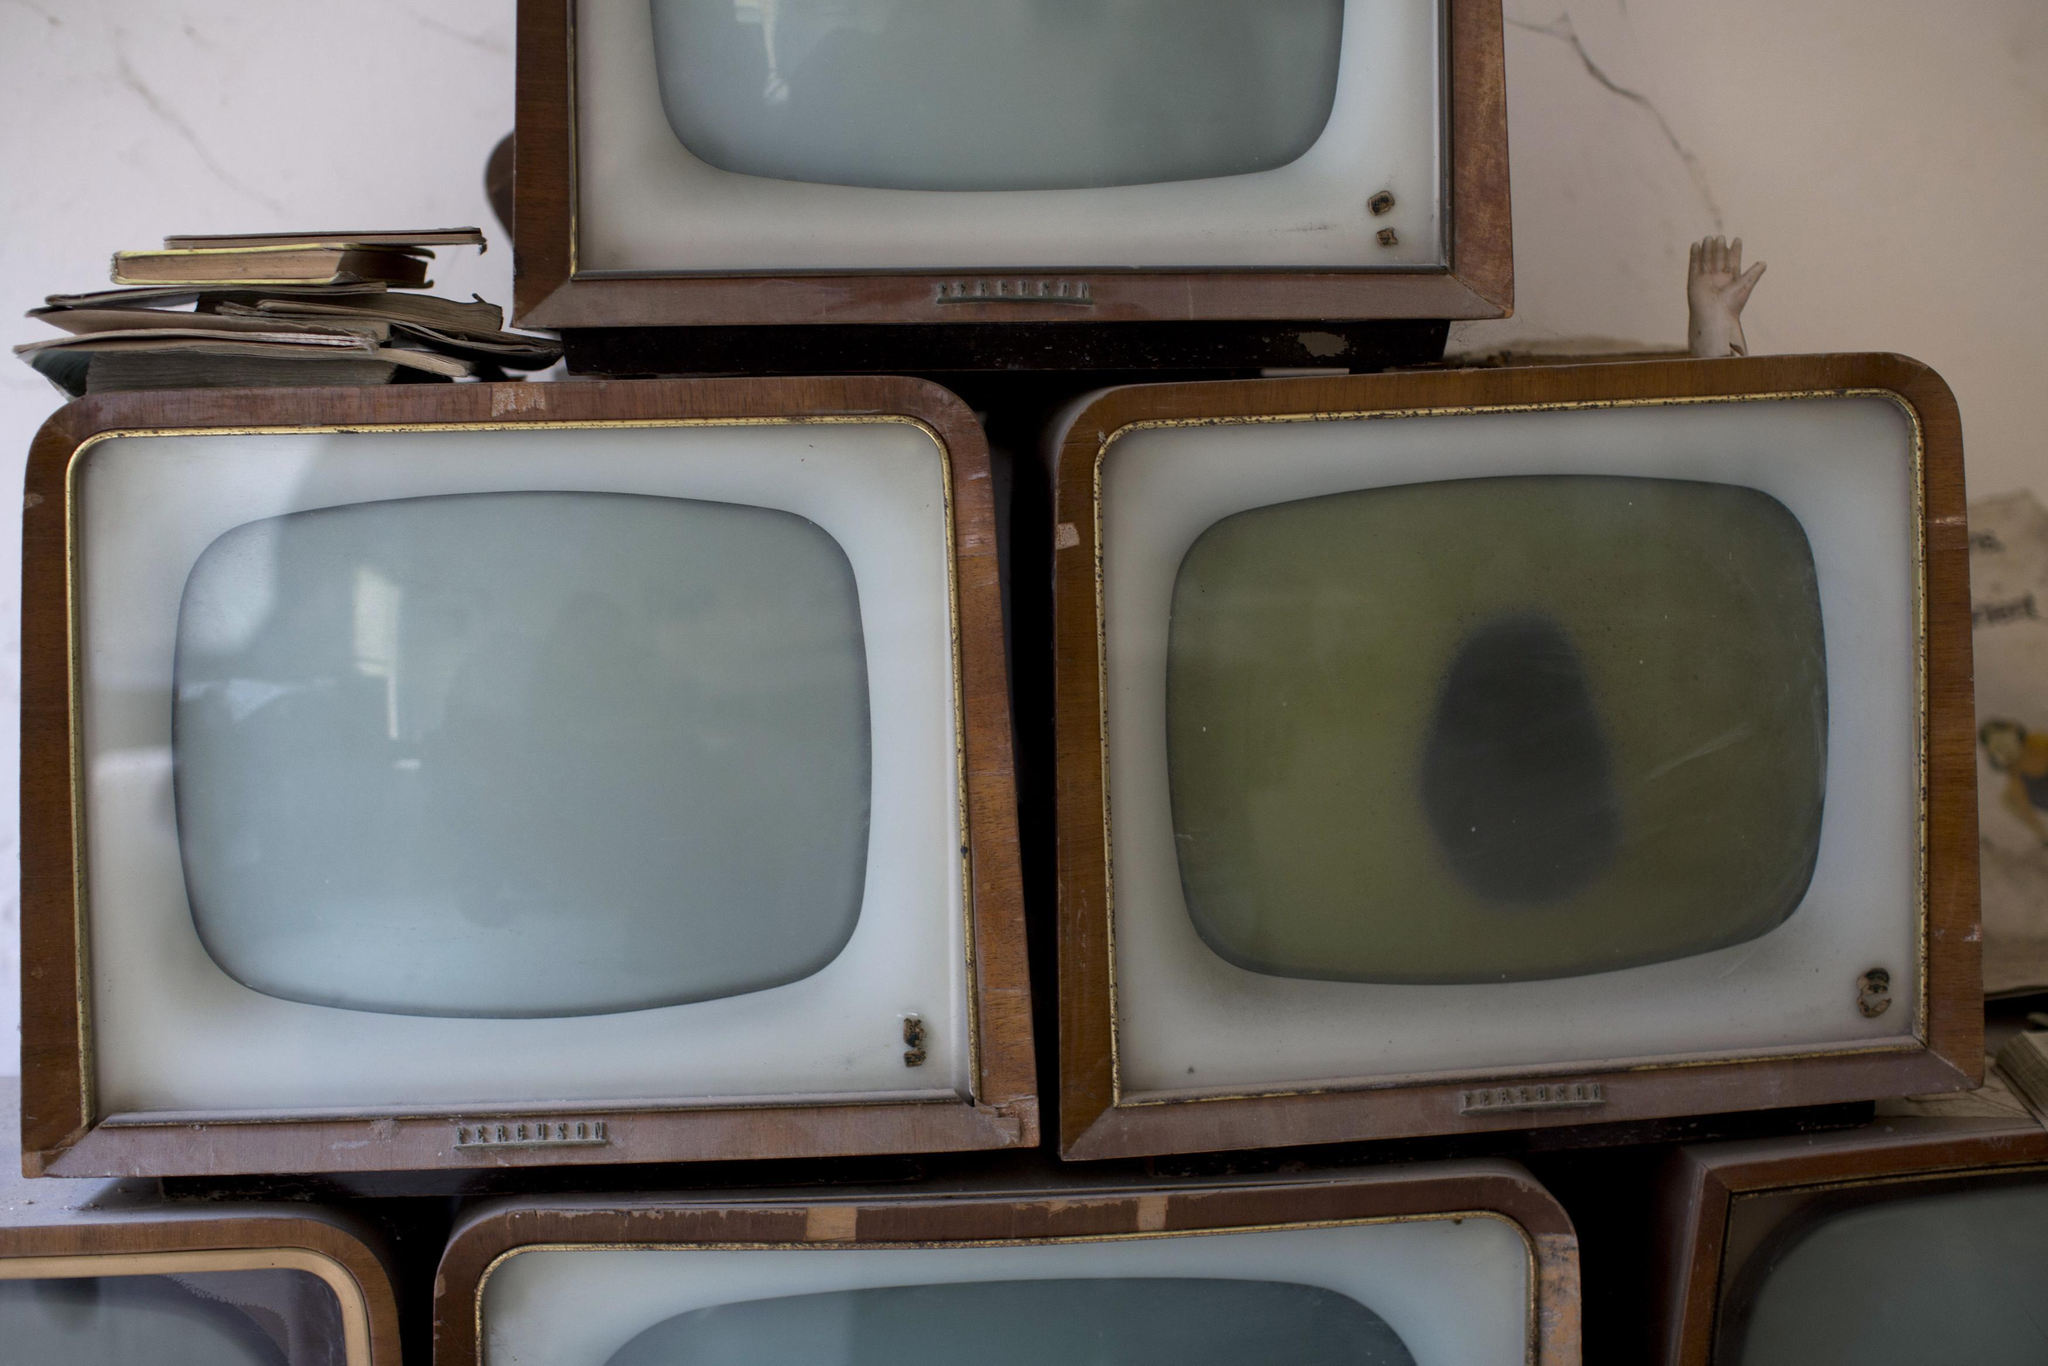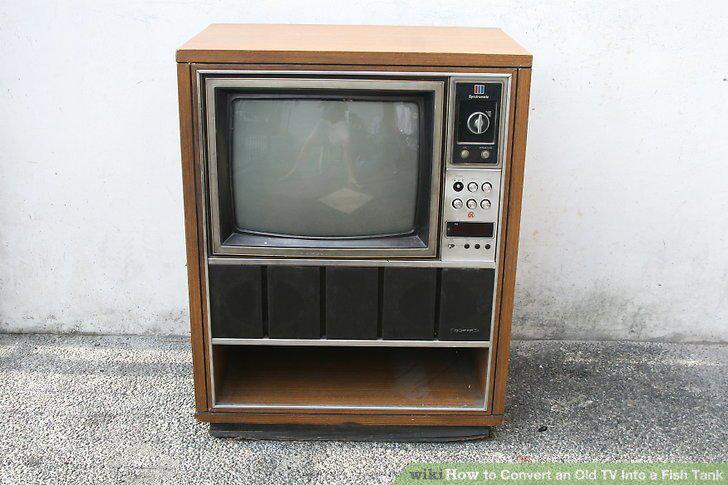The first image is the image on the left, the second image is the image on the right. Analyze the images presented: Is the assertion "Each image contains a single old-fashioned TV in the foreground, and in one image the TV has a picture on the screen." valid? Answer yes or no. No. The first image is the image on the left, the second image is the image on the right. For the images displayed, is the sentence "One of the two televisions is showing an image." factually correct? Answer yes or no. No. 